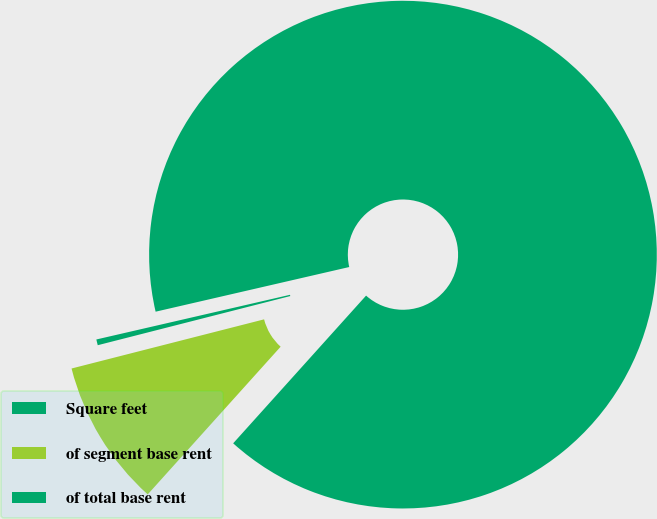Convert chart. <chart><loc_0><loc_0><loc_500><loc_500><pie_chart><fcel>Square feet<fcel>of segment base rent<fcel>of total base rent<nl><fcel>90.27%<fcel>9.36%<fcel>0.37%<nl></chart> 